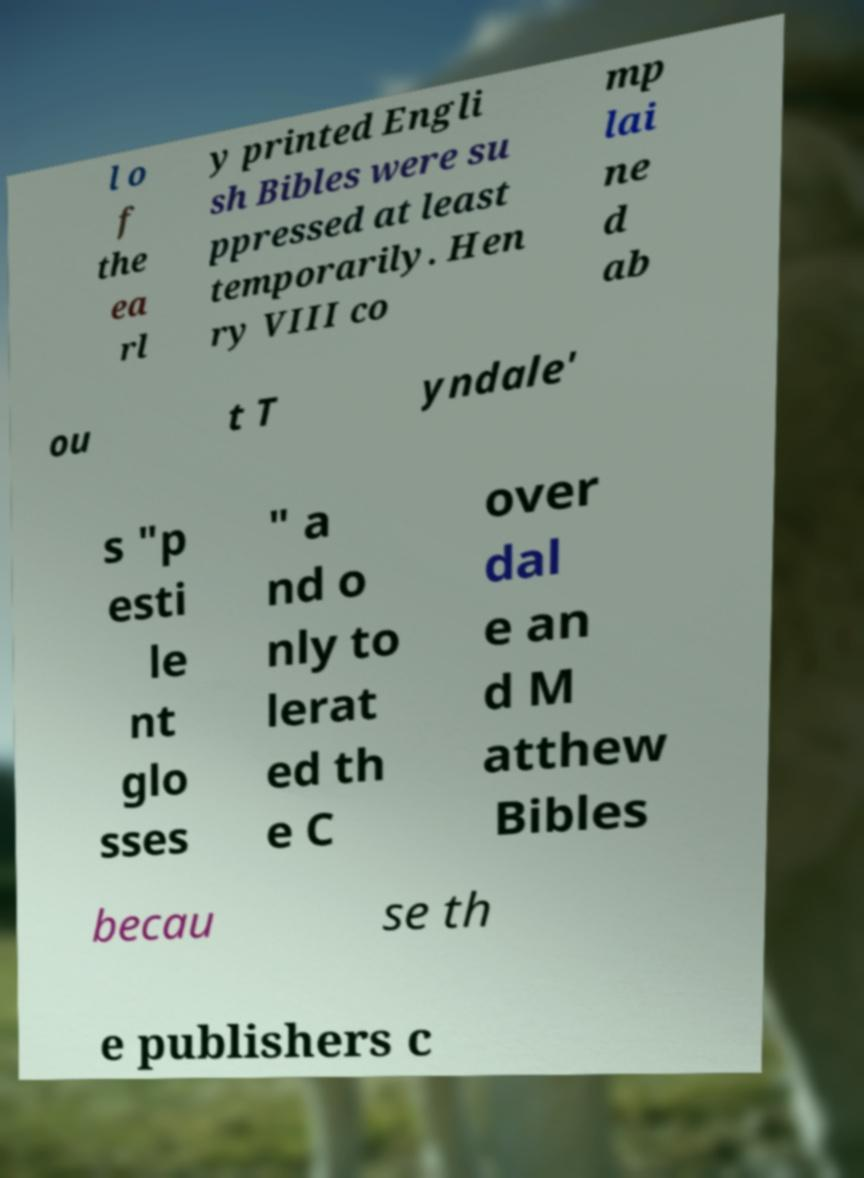Can you accurately transcribe the text from the provided image for me? l o f the ea rl y printed Engli sh Bibles were su ppressed at least temporarily. Hen ry VIII co mp lai ne d ab ou t T yndale' s "p esti le nt glo sses " a nd o nly to lerat ed th e C over dal e an d M atthew Bibles becau se th e publishers c 